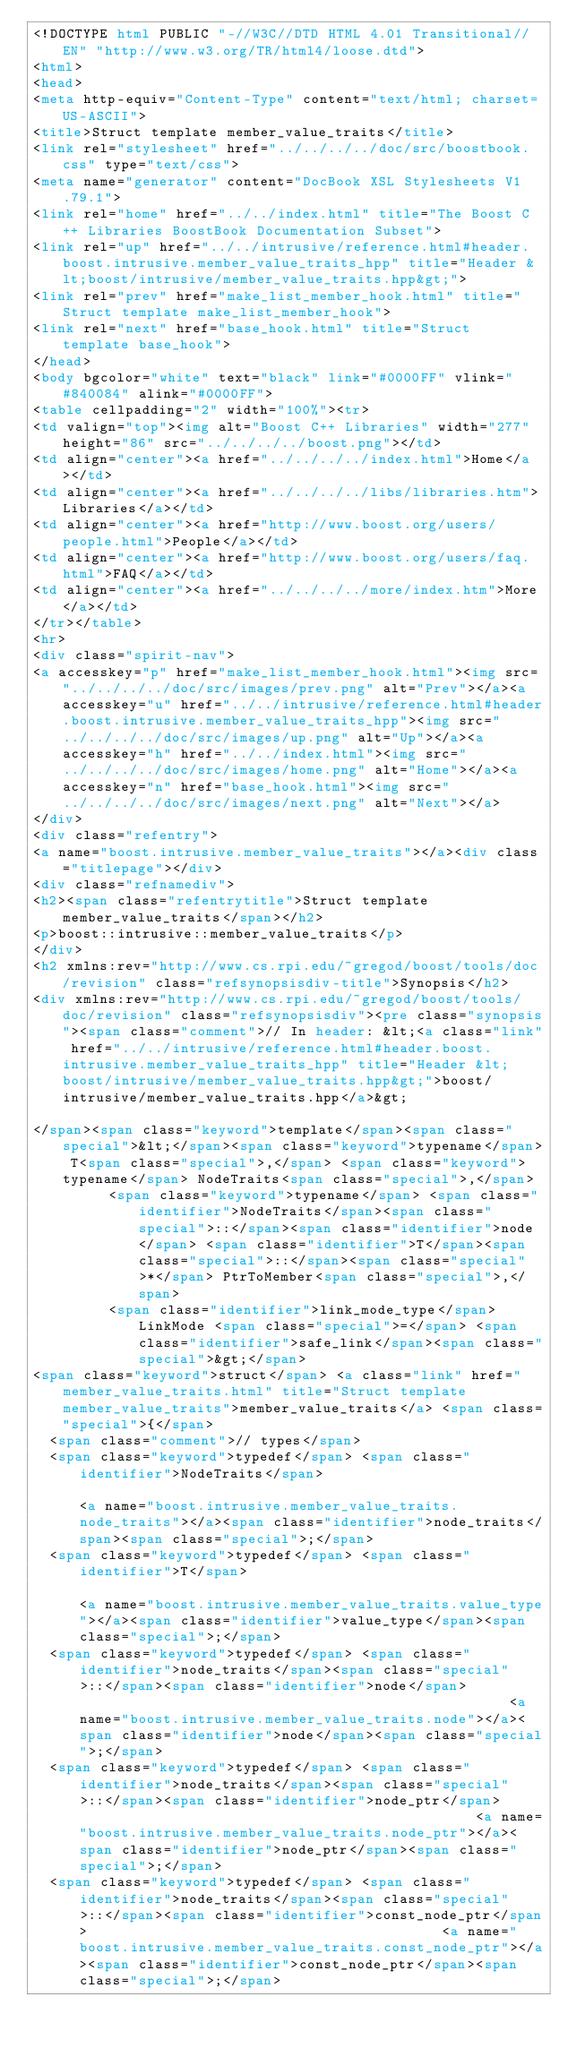<code> <loc_0><loc_0><loc_500><loc_500><_HTML_><!DOCTYPE html PUBLIC "-//W3C//DTD HTML 4.01 Transitional//EN" "http://www.w3.org/TR/html4/loose.dtd">
<html>
<head>
<meta http-equiv="Content-Type" content="text/html; charset=US-ASCII">
<title>Struct template member_value_traits</title>
<link rel="stylesheet" href="../../../../doc/src/boostbook.css" type="text/css">
<meta name="generator" content="DocBook XSL Stylesheets V1.79.1">
<link rel="home" href="../../index.html" title="The Boost C++ Libraries BoostBook Documentation Subset">
<link rel="up" href="../../intrusive/reference.html#header.boost.intrusive.member_value_traits_hpp" title="Header &lt;boost/intrusive/member_value_traits.hpp&gt;">
<link rel="prev" href="make_list_member_hook.html" title="Struct template make_list_member_hook">
<link rel="next" href="base_hook.html" title="Struct template base_hook">
</head>
<body bgcolor="white" text="black" link="#0000FF" vlink="#840084" alink="#0000FF">
<table cellpadding="2" width="100%"><tr>
<td valign="top"><img alt="Boost C++ Libraries" width="277" height="86" src="../../../../boost.png"></td>
<td align="center"><a href="../../../../index.html">Home</a></td>
<td align="center"><a href="../../../../libs/libraries.htm">Libraries</a></td>
<td align="center"><a href="http://www.boost.org/users/people.html">People</a></td>
<td align="center"><a href="http://www.boost.org/users/faq.html">FAQ</a></td>
<td align="center"><a href="../../../../more/index.htm">More</a></td>
</tr></table>
<hr>
<div class="spirit-nav">
<a accesskey="p" href="make_list_member_hook.html"><img src="../../../../doc/src/images/prev.png" alt="Prev"></a><a accesskey="u" href="../../intrusive/reference.html#header.boost.intrusive.member_value_traits_hpp"><img src="../../../../doc/src/images/up.png" alt="Up"></a><a accesskey="h" href="../../index.html"><img src="../../../../doc/src/images/home.png" alt="Home"></a><a accesskey="n" href="base_hook.html"><img src="../../../../doc/src/images/next.png" alt="Next"></a>
</div>
<div class="refentry">
<a name="boost.intrusive.member_value_traits"></a><div class="titlepage"></div>
<div class="refnamediv">
<h2><span class="refentrytitle">Struct template member_value_traits</span></h2>
<p>boost::intrusive::member_value_traits</p>
</div>
<h2 xmlns:rev="http://www.cs.rpi.edu/~gregod/boost/tools/doc/revision" class="refsynopsisdiv-title">Synopsis</h2>
<div xmlns:rev="http://www.cs.rpi.edu/~gregod/boost/tools/doc/revision" class="refsynopsisdiv"><pre class="synopsis"><span class="comment">// In header: &lt;<a class="link" href="../../intrusive/reference.html#header.boost.intrusive.member_value_traits_hpp" title="Header &lt;boost/intrusive/member_value_traits.hpp&gt;">boost/intrusive/member_value_traits.hpp</a>&gt;

</span><span class="keyword">template</span><span class="special">&lt;</span><span class="keyword">typename</span> T<span class="special">,</span> <span class="keyword">typename</span> NodeTraits<span class="special">,</span> 
         <span class="keyword">typename</span> <span class="identifier">NodeTraits</span><span class="special">::</span><span class="identifier">node</span> <span class="identifier">T</span><span class="special">::</span><span class="special">*</span> PtrToMember<span class="special">,</span> 
         <span class="identifier">link_mode_type</span> LinkMode <span class="special">=</span> <span class="identifier">safe_link</span><span class="special">&gt;</span> 
<span class="keyword">struct</span> <a class="link" href="member_value_traits.html" title="Struct template member_value_traits">member_value_traits</a> <span class="special">{</span>
  <span class="comment">// types</span>
  <span class="keyword">typedef</span> <span class="identifier">NodeTraits</span>                                                           <a name="boost.intrusive.member_value_traits.node_traits"></a><span class="identifier">node_traits</span><span class="special">;</span>    
  <span class="keyword">typedef</span> <span class="identifier">T</span>                                                                    <a name="boost.intrusive.member_value_traits.value_type"></a><span class="identifier">value_type</span><span class="special">;</span>     
  <span class="keyword">typedef</span> <span class="identifier">node_traits</span><span class="special">::</span><span class="identifier">node</span>                                                    <a name="boost.intrusive.member_value_traits.node"></a><span class="identifier">node</span><span class="special">;</span>           
  <span class="keyword">typedef</span> <span class="identifier">node_traits</span><span class="special">::</span><span class="identifier">node_ptr</span>                                                <a name="boost.intrusive.member_value_traits.node_ptr"></a><span class="identifier">node_ptr</span><span class="special">;</span>       
  <span class="keyword">typedef</span> <span class="identifier">node_traits</span><span class="special">::</span><span class="identifier">const_node_ptr</span>                                          <a name="boost.intrusive.member_value_traits.const_node_ptr"></a><span class="identifier">const_node_ptr</span><span class="special">;</span> </code> 